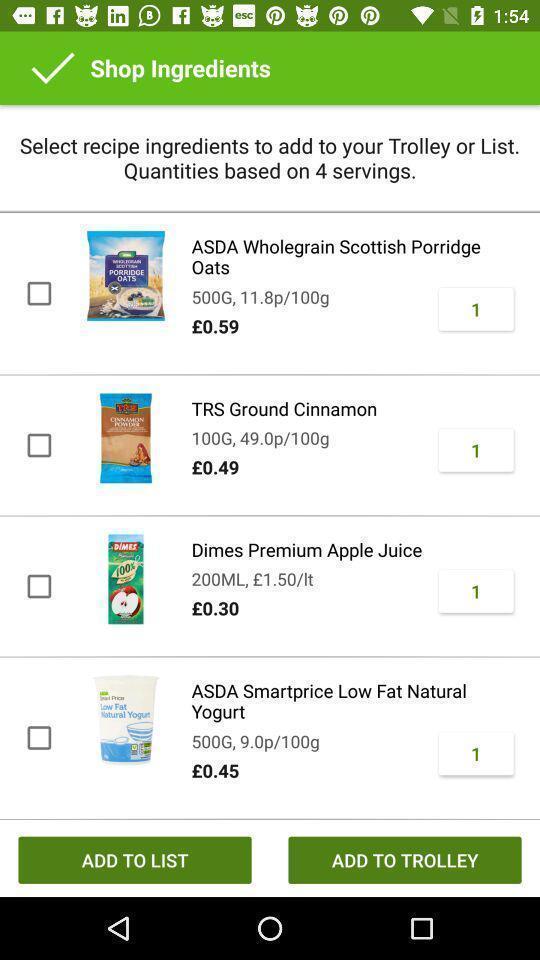Give me a narrative description of this picture. Screen displaying products details with price in a shopping application. 